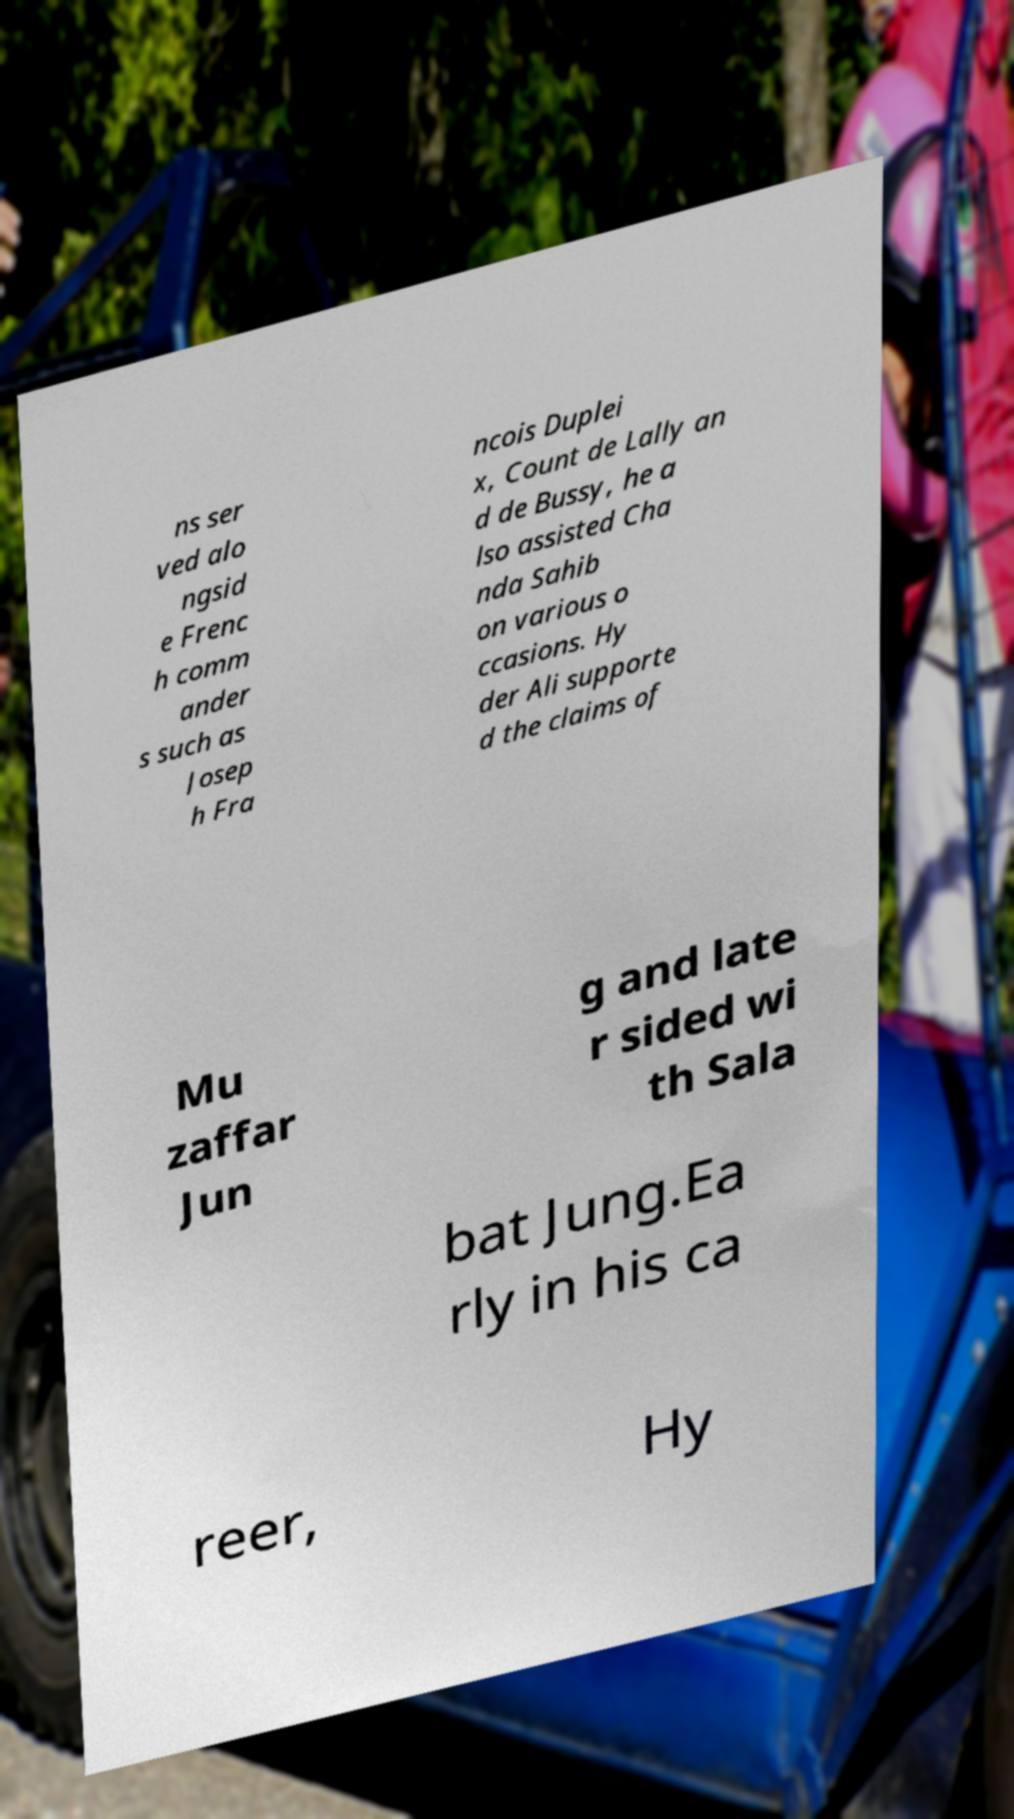Please identify and transcribe the text found in this image. ns ser ved alo ngsid e Frenc h comm ander s such as Josep h Fra ncois Duplei x, Count de Lally an d de Bussy, he a lso assisted Cha nda Sahib on various o ccasions. Hy der Ali supporte d the claims of Mu zaffar Jun g and late r sided wi th Sala bat Jung.Ea rly in his ca reer, Hy 